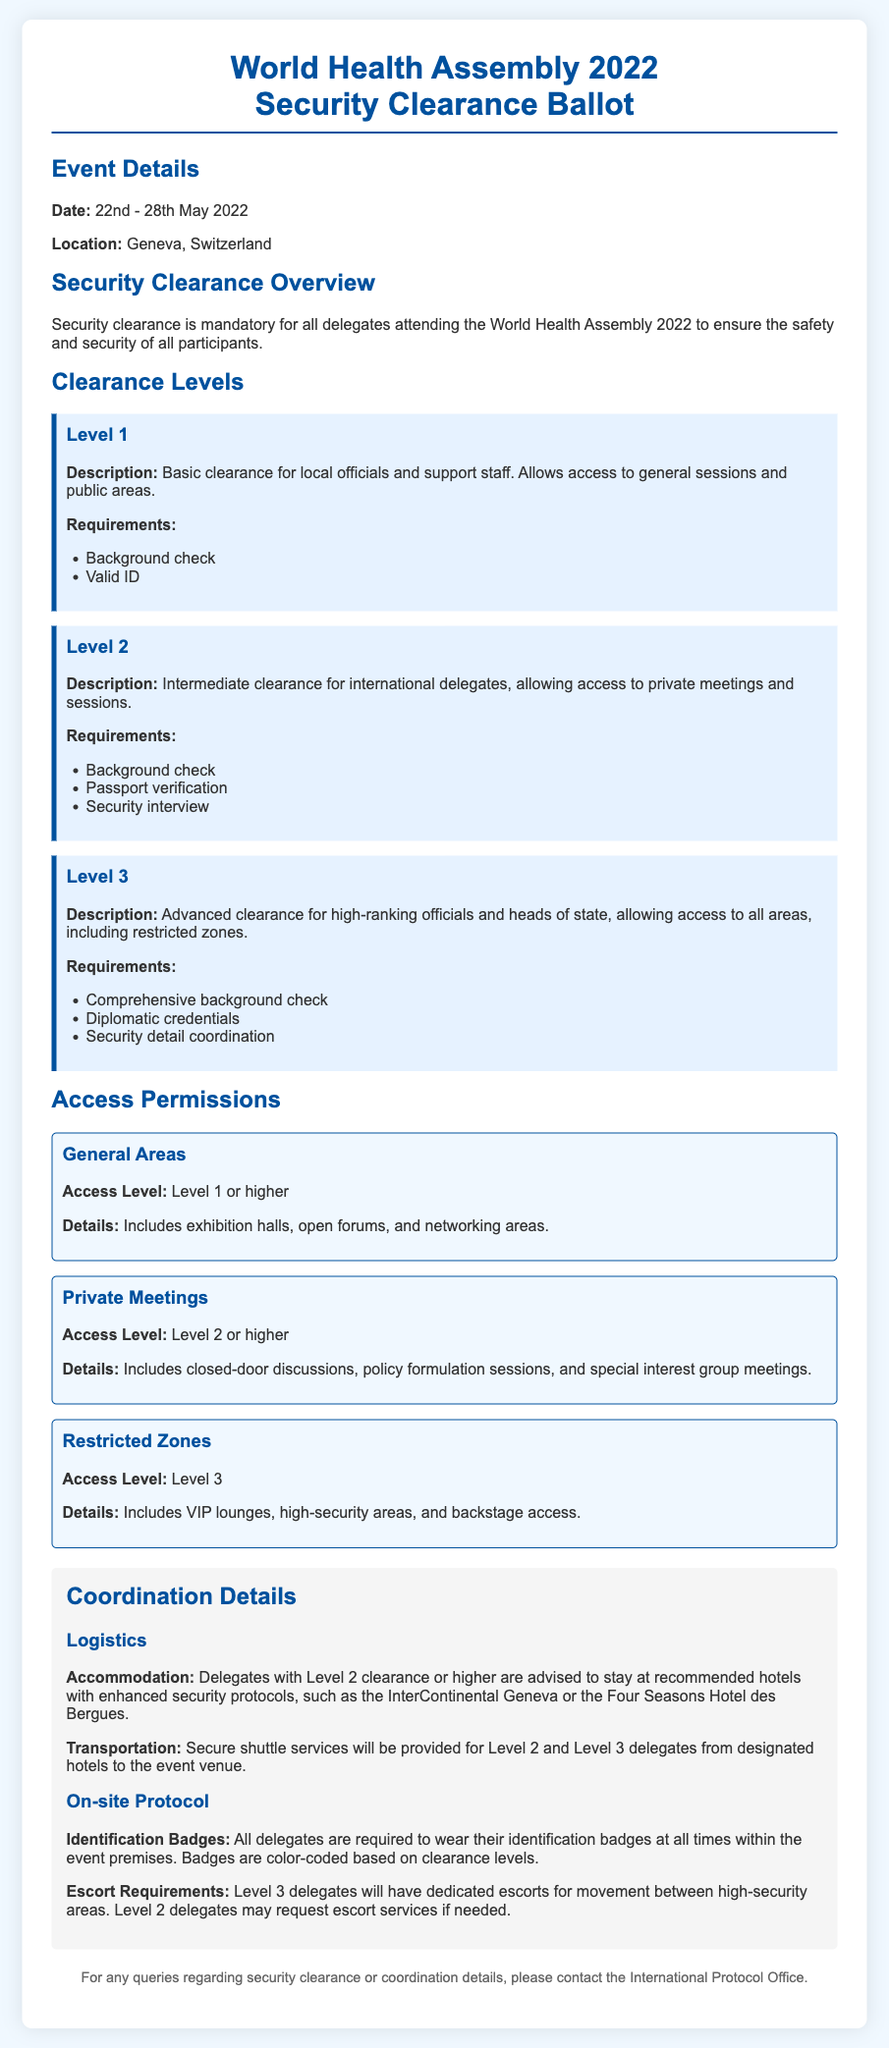what is the date of the World Health Assembly 2022? The date is specified in the event details section of the document.
Answer: 22nd - 28th May 2022 where is the World Health Assembly 2022 being held? The location is mentioned in the event details section of the document.
Answer: Geneva, Switzerland what is the access level for General Areas? The access level is indicated under the access permissions section for general areas.
Answer: Level 1 or higher what requirements are needed for Level 2 clearance? The requirements for Level 2 clearance are listed in the clearance levels section.
Answer: Background check, Passport verification, Security interview which hotel is recommended for delegates with Level 2 clearance? The recommended hotel for Level 2 or higher delegates is specified in the logistics section.
Answer: InterContinental Geneva how are identification badges categorized? The categorization of identification badges is mentioned in the on-site protocol section.
Answer: Color-coded based on clearance levels what is allowed with Level 3 clearance? The permissions for Level 3 clearance are outlined in the access permissions section.
Answer: Access to all areas, including restricted zones what kind of escorts are provided to Level 3 delegates? The escort services for Level 3 delegates are detailed in the on-site protocol section.
Answer: Dedicated escorts for high-security areas 